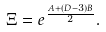Convert formula to latex. <formula><loc_0><loc_0><loc_500><loc_500>\Xi = e ^ { \frac { A + ( D - 3 ) B } { 2 } } .</formula> 